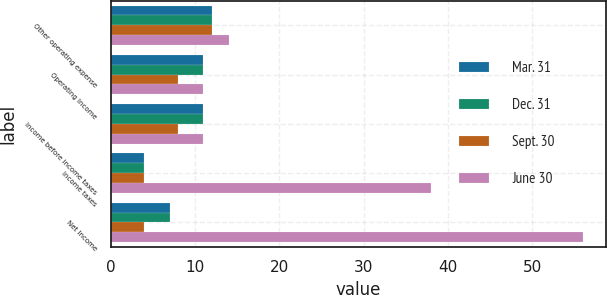Convert chart. <chart><loc_0><loc_0><loc_500><loc_500><stacked_bar_chart><ecel><fcel>Other operating expense<fcel>Operating Income<fcel>Income before income taxes<fcel>Income taxes<fcel>Net Income<nl><fcel>Mar. 31<fcel>12<fcel>11<fcel>11<fcel>4<fcel>7<nl><fcel>Dec. 31<fcel>12<fcel>11<fcel>11<fcel>4<fcel>7<nl><fcel>Sept. 30<fcel>12<fcel>8<fcel>8<fcel>4<fcel>4<nl><fcel>June 30<fcel>14<fcel>11<fcel>11<fcel>38<fcel>56<nl></chart> 